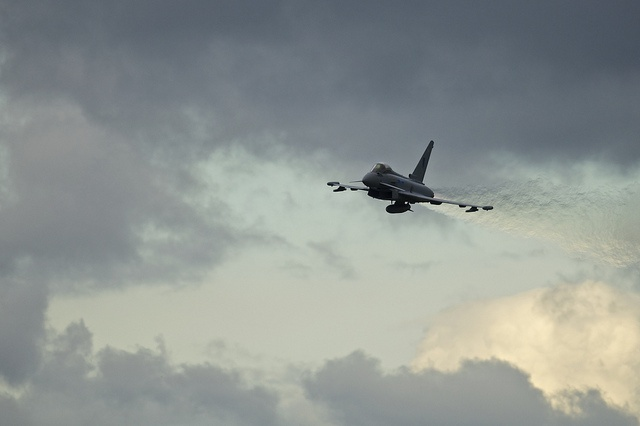Describe the objects in this image and their specific colors. I can see a airplane in gray, black, and darkgray tones in this image. 